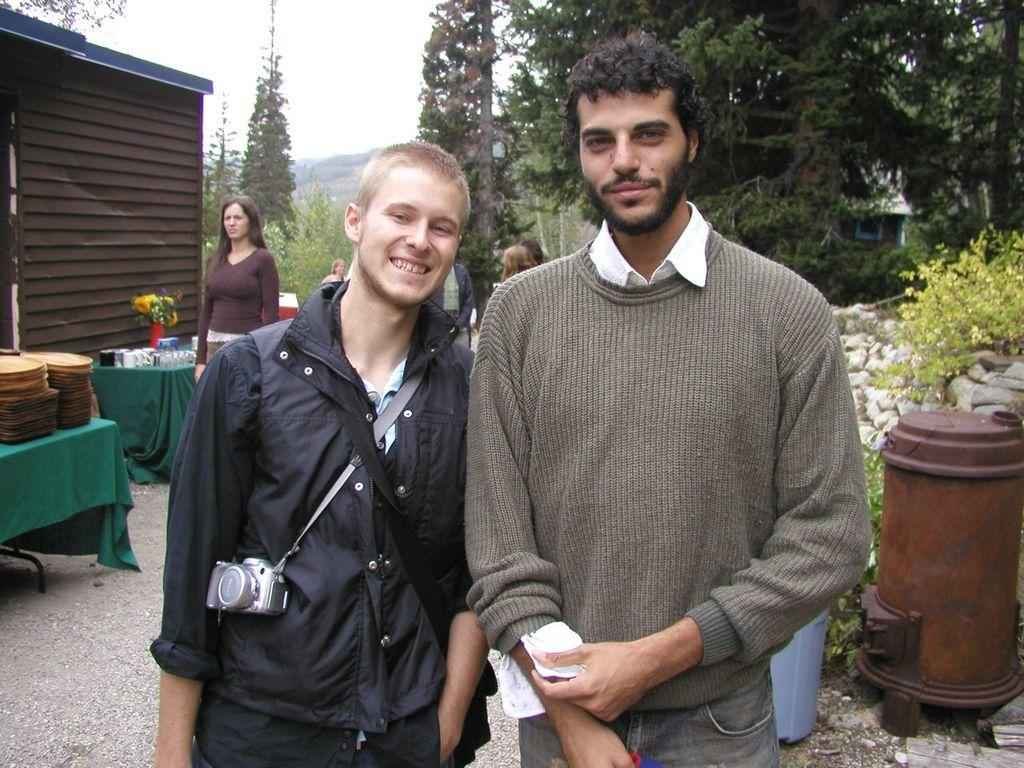How many people are in the image? There are people in the image, but the exact number is not specified. What type of natural elements can be seen in the image? There are trees in the image. What type of ground elements can be seen in the image? There are stones in the image. What type of furniture can be seen in the image? There are tables in the image. What type of container for plants can be seen in the image? There is a flower pot in the image. What type of material can be seen in the image? There is cloth in the image. What other objects can be seen in the image? There are other objects in the image, but their specific nature is not specified. How many apples are on the table in the image? There is no mention of apples in the image, so we cannot determine their number. What type of house is visible in the image? There is no house present in the image. What type of spot can be seen on the cloth in the image? There is no mention of a spot on the cloth in the image. 